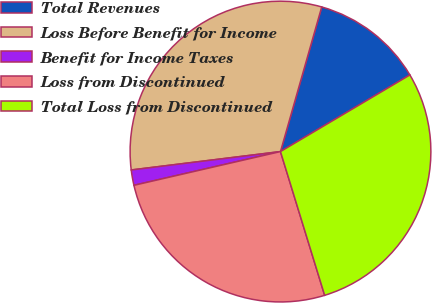Convert chart. <chart><loc_0><loc_0><loc_500><loc_500><pie_chart><fcel>Total Revenues<fcel>Loss Before Benefit for Income<fcel>Benefit for Income Taxes<fcel>Loss from Discontinued<fcel>Total Loss from Discontinued<nl><fcel>12.07%<fcel>31.37%<fcel>1.65%<fcel>26.14%<fcel>28.76%<nl></chart> 